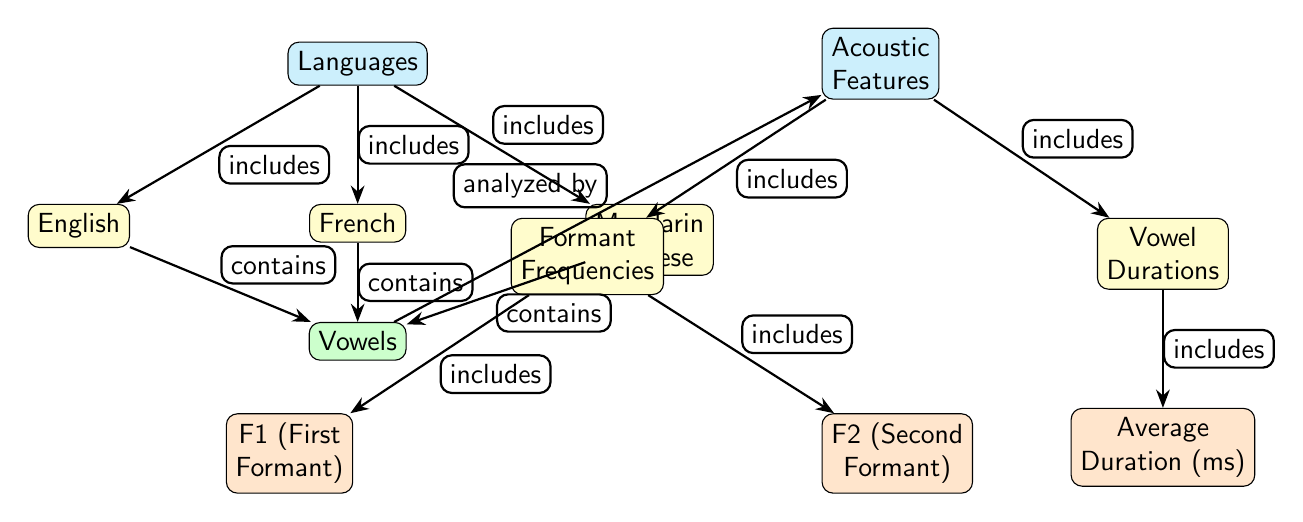What are the three languages depicted in the diagram? The diagram shows three branches leading to different languages. These branches are labeled as English, French, and Mandarin Chinese, directly representing the languages analyzed.
Answer: English, French, Mandarin Chinese How many main categories are present in the diagram? Upon examining the diagram, there are two main categories: Languages and Acoustic Features. Each category has its respective sub-nodes.
Answer: 2 What vowel property is analyzed from all three languages? The diagram indicates that the vowels from English, French, and Mandarin Chinese are all analyzed by the acoustic features. This analysis directly pertains to the acoustic properties of the vowels.
Answer: Vowels Which acoustic feature has two subcategories? The acoustic feature of "Formant Frequencies" is illustrated in the diagram as having two subcategories: F1 (First Formant) and F2 (Second Formant). This connects it to its detailed acoustic analysis.
Answer: Formant Frequencies What is the relationship between "Acoustic Features" and "Vowels"? The diagram shows an upward arrow indicating the relationship where Vowels are analyzed by Acoustic Features, illustrating how specific vowel sounds relate to their acoustic characteristics.
Answer: Analyzed by What is the average duration of vowels associated with in the diagram? The Average Duration is a subcategory under the Acoustic Features, specifically linked to Vowel Durations. This shows its relationship with the time aspect of how vowels are produced.
Answer: Average Duration Which language is shown below English in the diagram? The diagram illustrates a clear positional arrangement where French is placed directly below English, indicating a hierarchy of languages based on the diagram’s structure.
Answer: French How many edges connect to the "Vowels" node? To find the number of edges connecting to the Vowels node, we count the connections. It is linked to English, French, and Mandarin Chinese, leading to a total of three edges.
Answer: 3 Which acoustic feature includes the measurement of F1? The diagram shows that F1 (First Formant) is included within the Formant Frequencies category, linking it directly to the analysis of unit acoustic properties.
Answer: F1 (First Formant) 